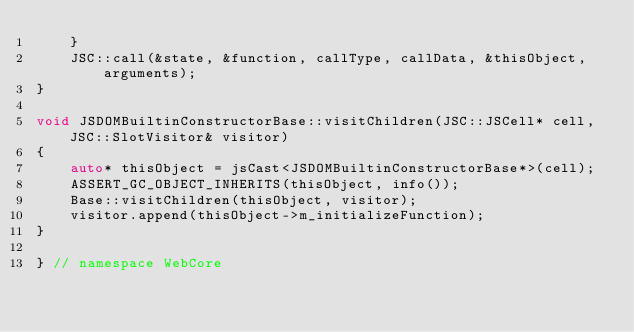<code> <loc_0><loc_0><loc_500><loc_500><_C++_>    }
    JSC::call(&state, &function, callType, callData, &thisObject, arguments);
}

void JSDOMBuiltinConstructorBase::visitChildren(JSC::JSCell* cell, JSC::SlotVisitor& visitor)
{
    auto* thisObject = jsCast<JSDOMBuiltinConstructorBase*>(cell);
    ASSERT_GC_OBJECT_INHERITS(thisObject, info());
    Base::visitChildren(thisObject, visitor);
    visitor.append(thisObject->m_initializeFunction);
}

} // namespace WebCore
</code> 